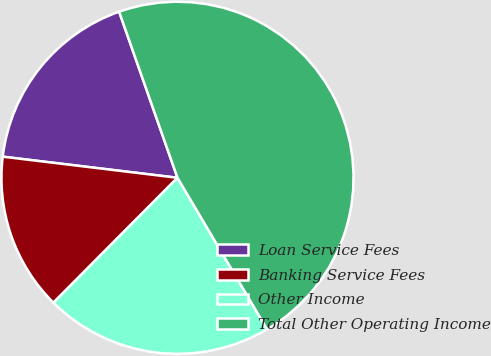Convert chart to OTSL. <chart><loc_0><loc_0><loc_500><loc_500><pie_chart><fcel>Loan Service Fees<fcel>Banking Service Fees<fcel>Other Income<fcel>Total Other Operating Income<nl><fcel>17.71%<fcel>14.47%<fcel>20.95%<fcel>46.88%<nl></chart> 